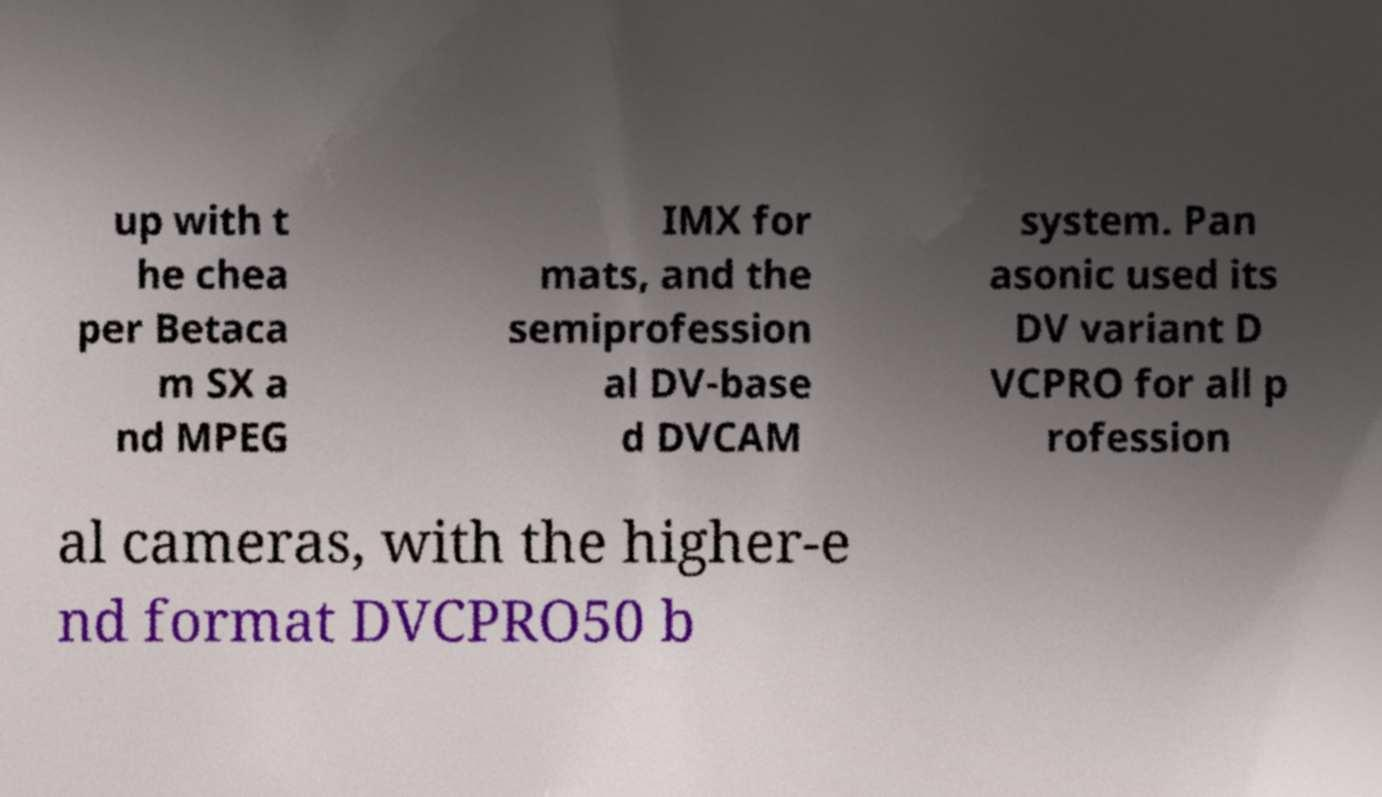I need the written content from this picture converted into text. Can you do that? up with t he chea per Betaca m SX a nd MPEG IMX for mats, and the semiprofession al DV-base d DVCAM system. Pan asonic used its DV variant D VCPRO for all p rofession al cameras, with the higher-e nd format DVCPRO50 b 